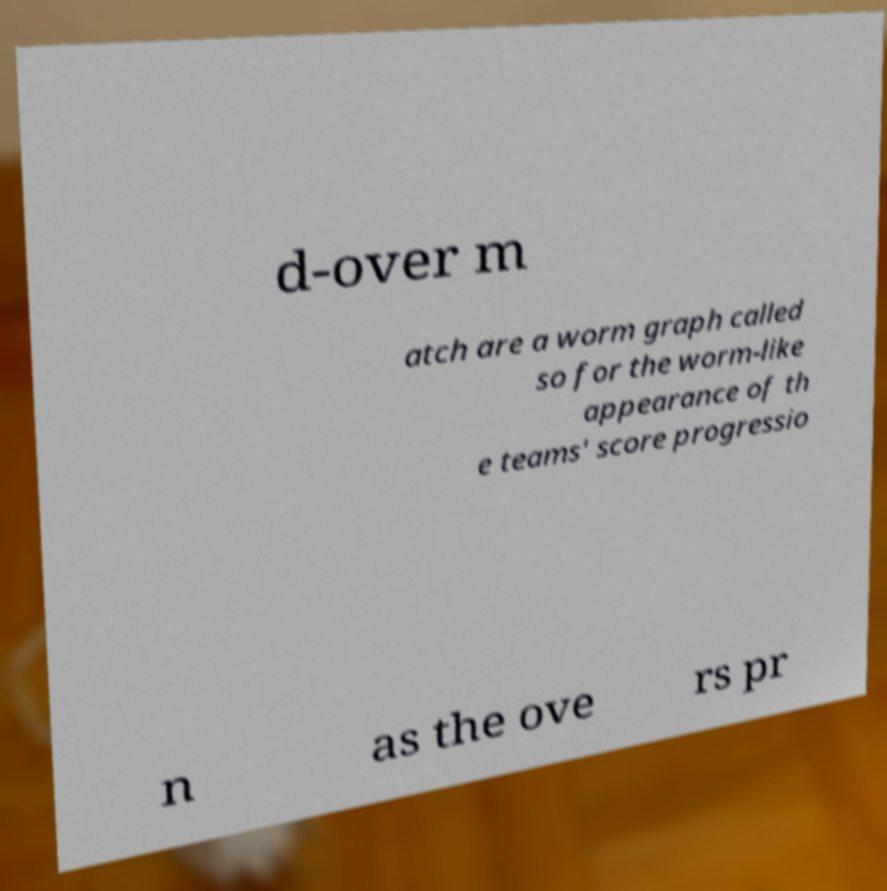Please identify and transcribe the text found in this image. d-over m atch are a worm graph called so for the worm-like appearance of th e teams' score progressio n as the ove rs pr 